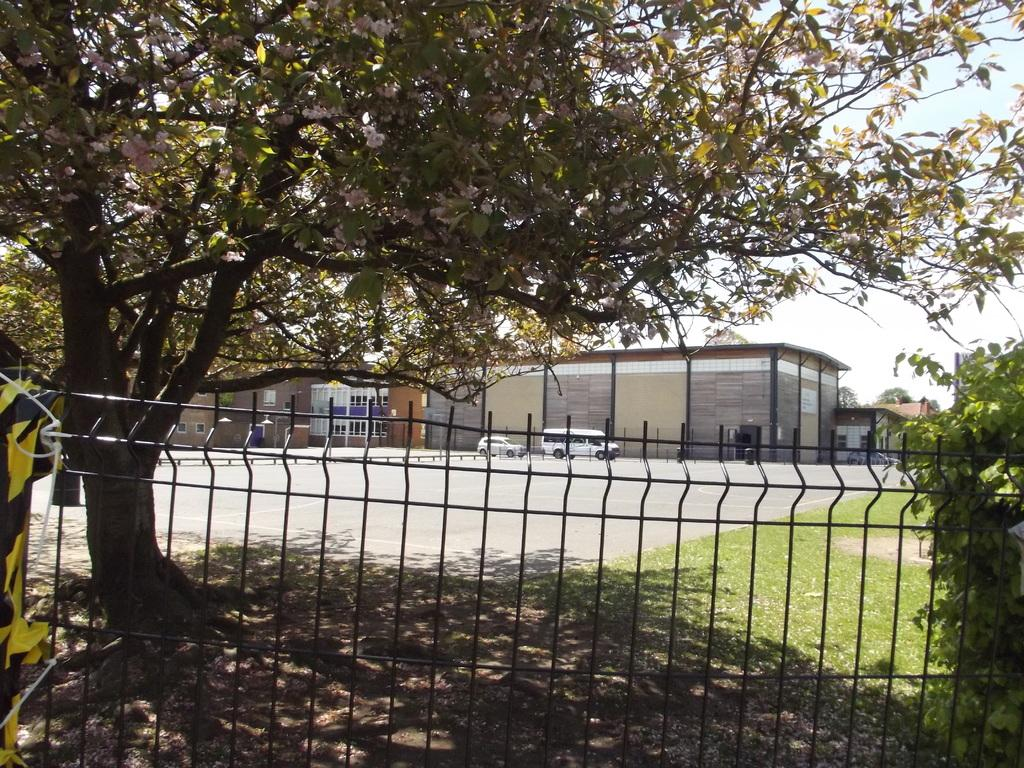What type of vegetation is present in the image? There are trees with green color in the image. What can be seen near the trees in the image? There is railing in the image. What is visible in the background of the image? There are vehicles and a building with a cream color visible in the background of the image. What is the color of the sky in the image? The sky appears to be white in color. What type of verse can be heard being recited in the image? There is no indication of any verse or recitation in the image; it primarily features trees, railing, vehicles, a building, and the sky. 